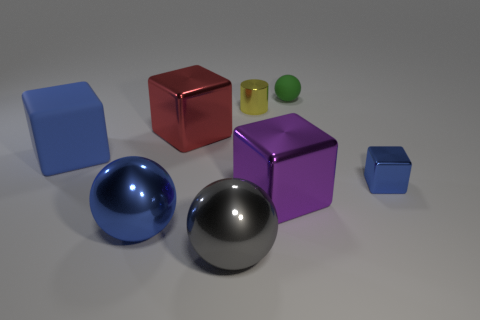Add 1 gray things. How many objects exist? 9 Subtract all cylinders. How many objects are left? 7 Subtract 1 purple blocks. How many objects are left? 7 Subtract all large purple blocks. Subtract all large purple metal blocks. How many objects are left? 6 Add 8 green matte balls. How many green matte balls are left? 9 Add 8 shiny spheres. How many shiny spheres exist? 10 